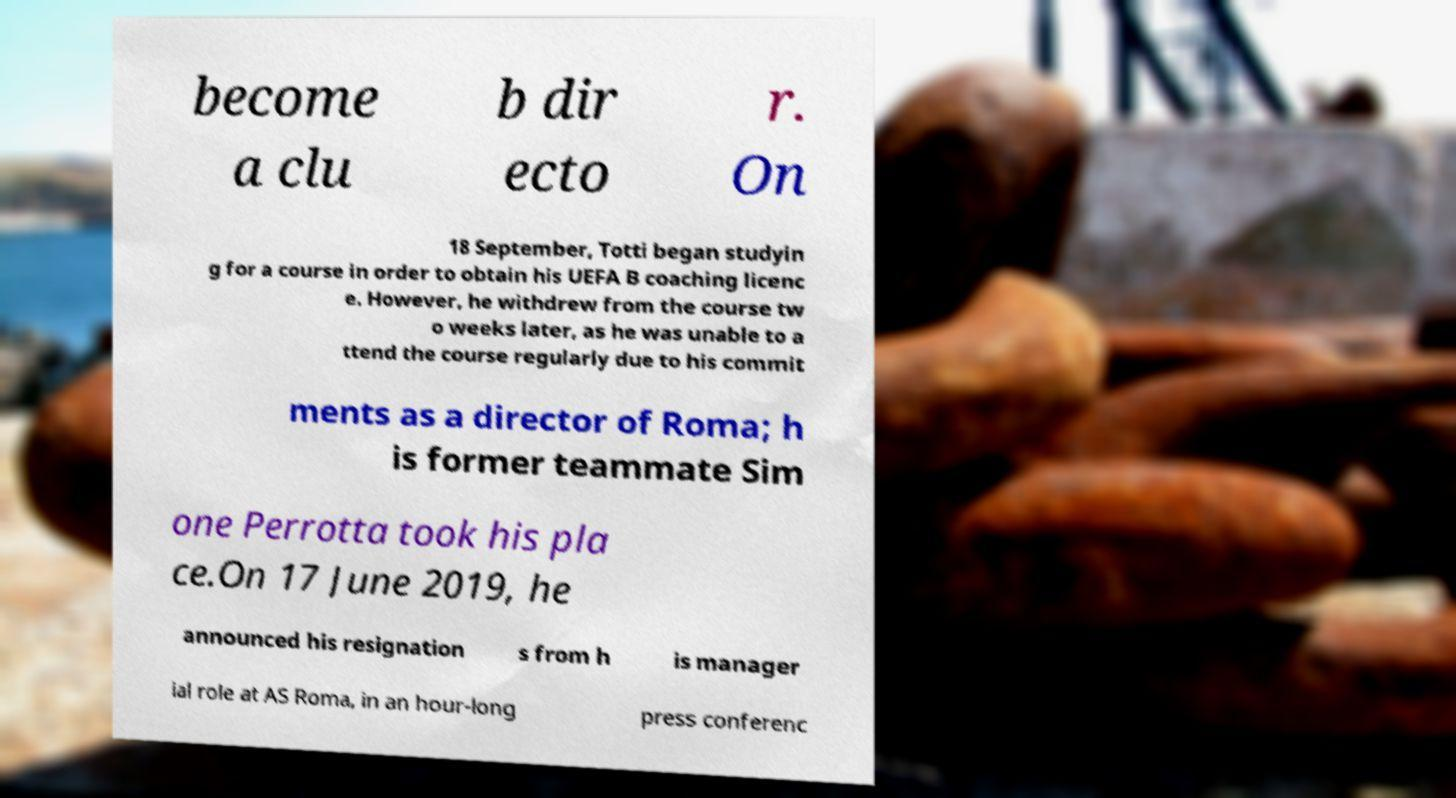Please identify and transcribe the text found in this image. become a clu b dir ecto r. On 18 September, Totti began studyin g for a course in order to obtain his UEFA B coaching licenc e. However, he withdrew from the course tw o weeks later, as he was unable to a ttend the course regularly due to his commit ments as a director of Roma; h is former teammate Sim one Perrotta took his pla ce.On 17 June 2019, he announced his resignation s from h is manager ial role at AS Roma, in an hour-long press conferenc 